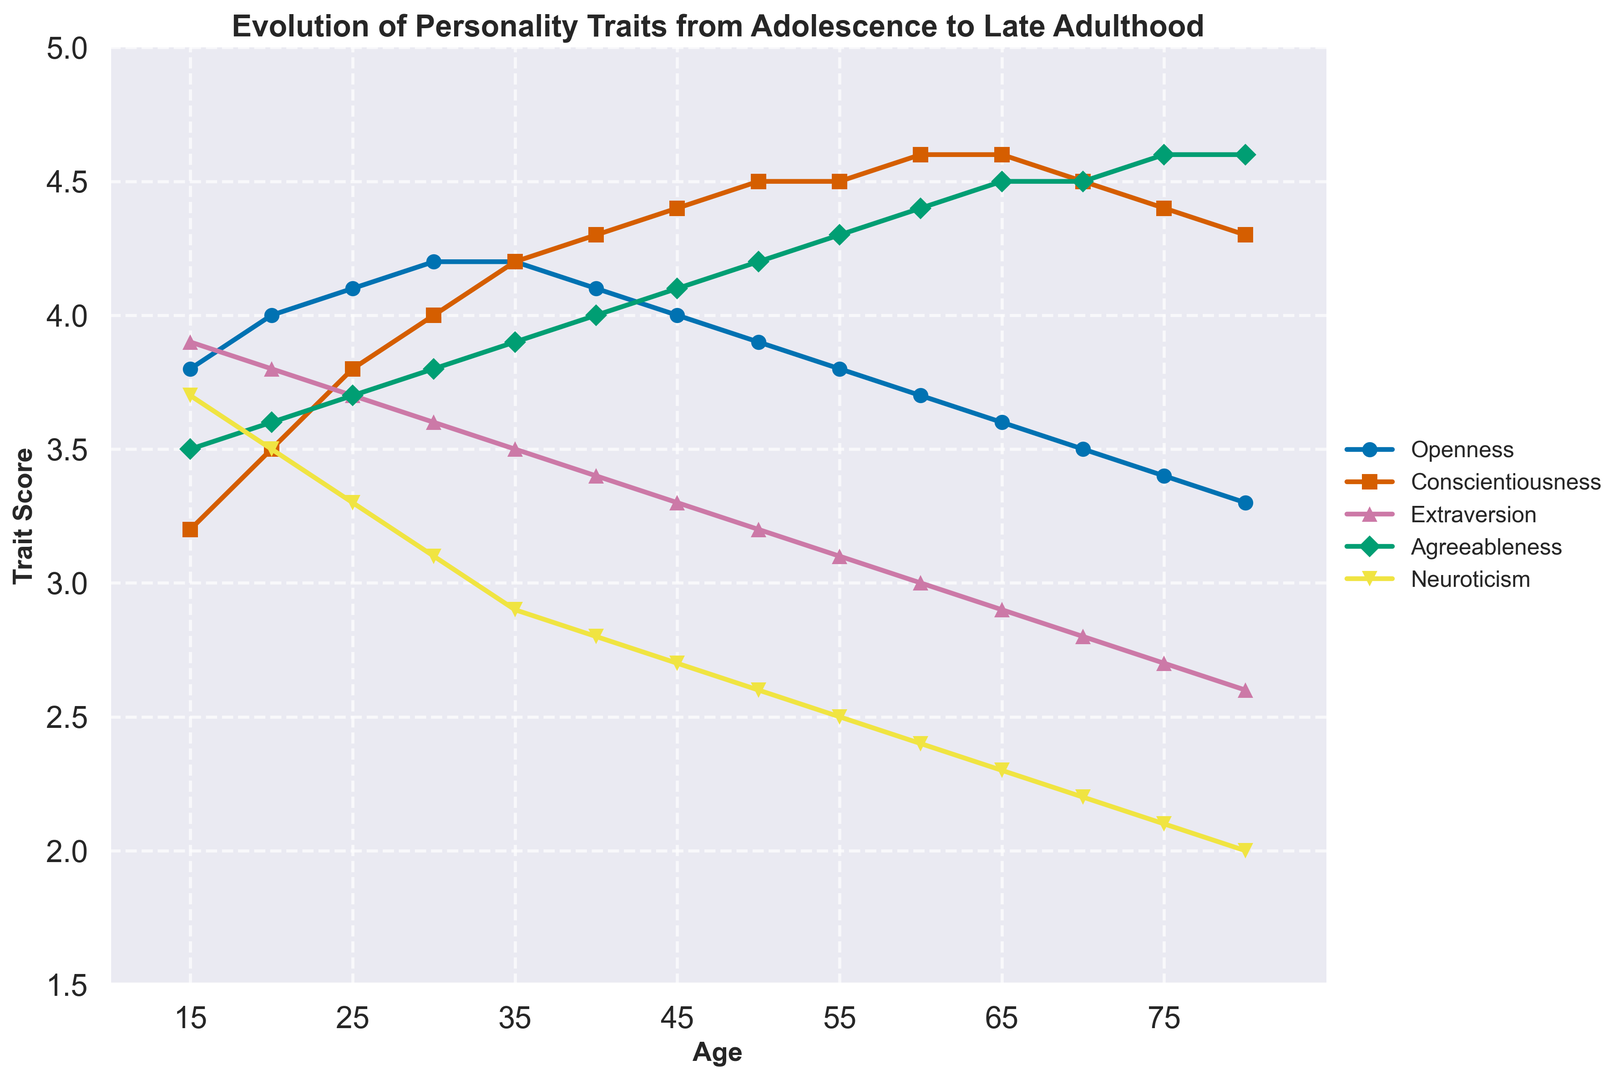What's the trend in Openness from age 15 to age 80? Openness starts at 3.8 at age 15, increases to a peak of 4.2 at ages 30 and 35, and then gradually decreases to 3.3 by age 80.
Answer: Declining Which trait shows the most consistent increase from age 15 to age 80? Conscientiousness shows a consistent increase from 3.2 at age 15 to 4.6 at ages 60 and 65, before slightly decreasing to 4.3 at age 80.
Answer: Conscientiousness At what age does Neuroticism reach its lowest point? Looking at the line for Neuroticism, the lowest point occurs at age 80 with a score of 2.0.
Answer: 80 Between ages 25 and 45, how much does Agreeableness increase? At age 25, Agreeableness is 3.7 and increases to 4.1 at age 45. The increase is 4.1 - 3.7 = 0.4.
Answer: 0.4 Compare Extraversion at ages 20 and 70. Which age has a higher score and by how much? At age 20, Extraversion is 3.8, and at age 70, it is 2.8. The score is higher at age 20 by 3.8 - 2.8 = 1.0.
Answer: Age 20 by 1.0 What is the general trend of Agreeableness as individuals age from 15 to 80? Agreeableness starts at 3.5 at age 15 and increases steadily, reaching 4.6 at age 75 and remaining stable at 4.6 at age 80.
Answer: Increasing By how many points does Conscientiousness increase between ages 15 and 55? Conscientiousness is 3.2 at age 15 and 4.5 at age 55. The increase is 4.5 - 3.2 = 1.3.
Answer: 1.3 Which trait exhibits the most noticeable decline from age 15 to age 80? Extraversion shows a noticeable decline from 3.9 at age 15 to 2.6 at age 80.
Answer: Extraversion Between ages 15 and 80, which two traits show the most opposite trends? Conscientiousness shows a consistent increase, while Extraversion shows a consistent decrease.
Answer: Conscientiousness and Extraversion How does Neuroticism change from age 15 to age 35? Neuroticism decreases from 3.7 at age 15 to 3.1 at age 30 and further down to 2.9 at age 35.
Answer: Decreases 